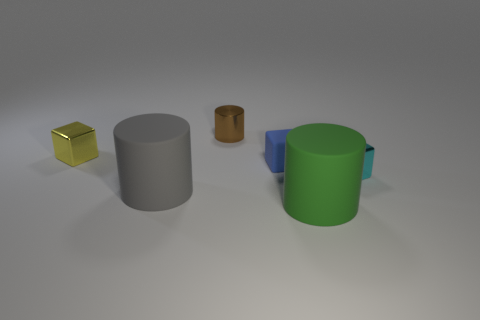There is a big thing that is left of the large green rubber thing; how many large rubber things are behind it?
Make the answer very short. 0. What number of large cyan spheres are made of the same material as the small brown cylinder?
Keep it short and to the point. 0. How many small things are gray rubber objects or cubes?
Make the answer very short. 3. The thing that is both behind the small blue rubber block and in front of the metallic cylinder has what shape?
Your answer should be very brief. Cube. Are the large gray cylinder and the small brown object made of the same material?
Make the answer very short. No. What color is the object that is the same size as the green rubber cylinder?
Your answer should be compact. Gray. What color is the thing that is to the left of the brown object and in front of the small cyan cube?
Your answer should be compact. Gray. There is a rubber cylinder that is to the left of the large cylinder in front of the large rubber object that is behind the large green thing; what size is it?
Give a very brief answer. Large. What is the yellow cube made of?
Your answer should be very brief. Metal. Do the brown cylinder and the block in front of the blue matte object have the same material?
Keep it short and to the point. Yes. 